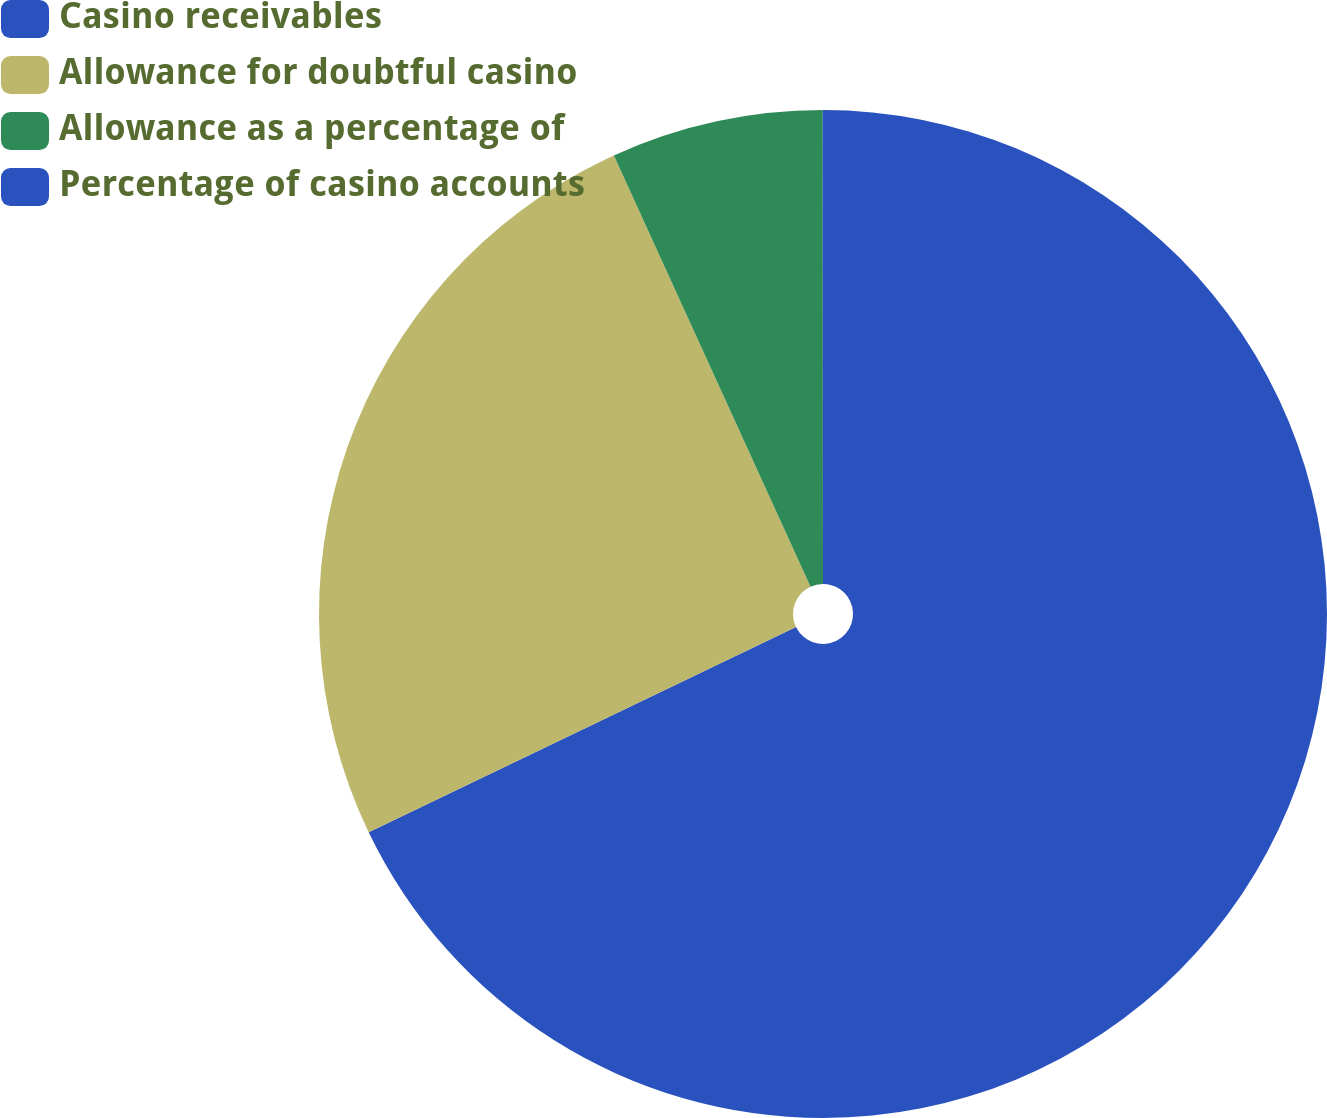Convert chart to OTSL. <chart><loc_0><loc_0><loc_500><loc_500><pie_chart><fcel>Casino receivables<fcel>Allowance for doubtful casino<fcel>Allowance as a percentage of<fcel>Percentage of casino accounts<nl><fcel>67.88%<fcel>25.32%<fcel>6.8%<fcel>0.01%<nl></chart> 